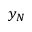<formula> <loc_0><loc_0><loc_500><loc_500>y _ { N }</formula> 